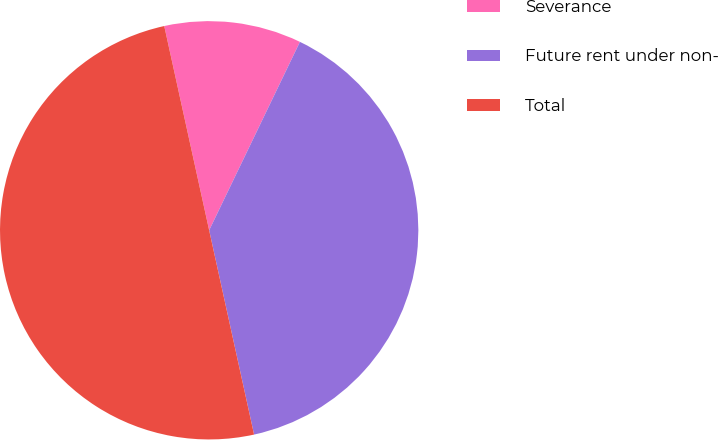<chart> <loc_0><loc_0><loc_500><loc_500><pie_chart><fcel>Severance<fcel>Future rent under non-<fcel>Total<nl><fcel>10.59%<fcel>39.41%<fcel>50.0%<nl></chart> 